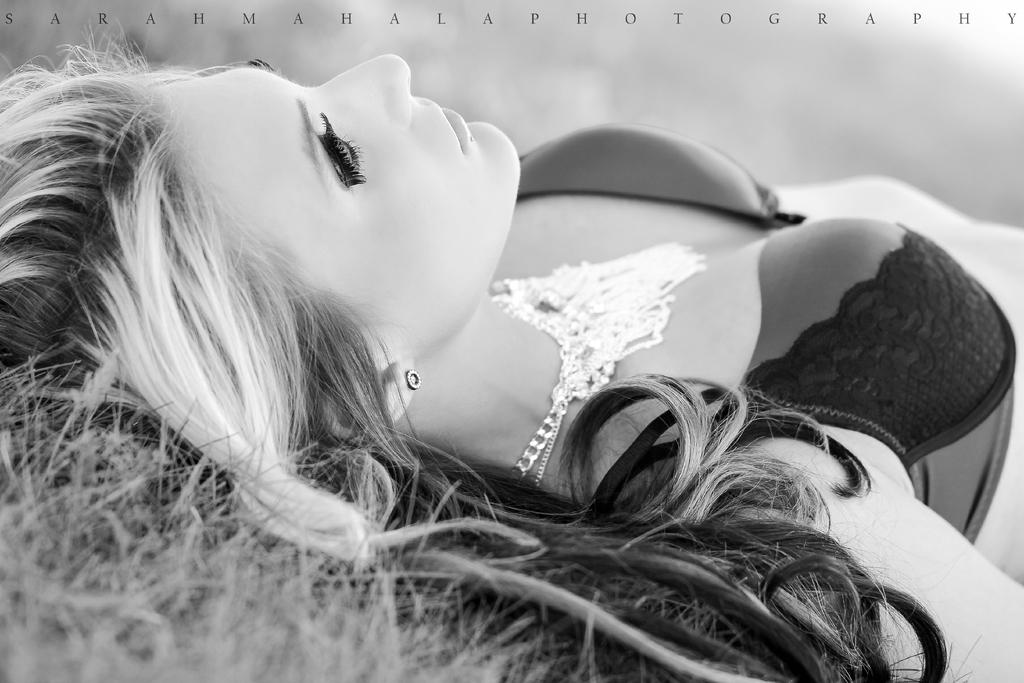Who is present in the image? There is a woman in the image. What is the woman doing in the image? The woman is lying on the grass. Can you describe the jewelry item the woman is wearing? The woman is wearing a jewelry item on her neck. What type of ants can be seen crawling on the woman's necklace in the image? There are no ants present in the image, and therefore no such activity can be observed. 